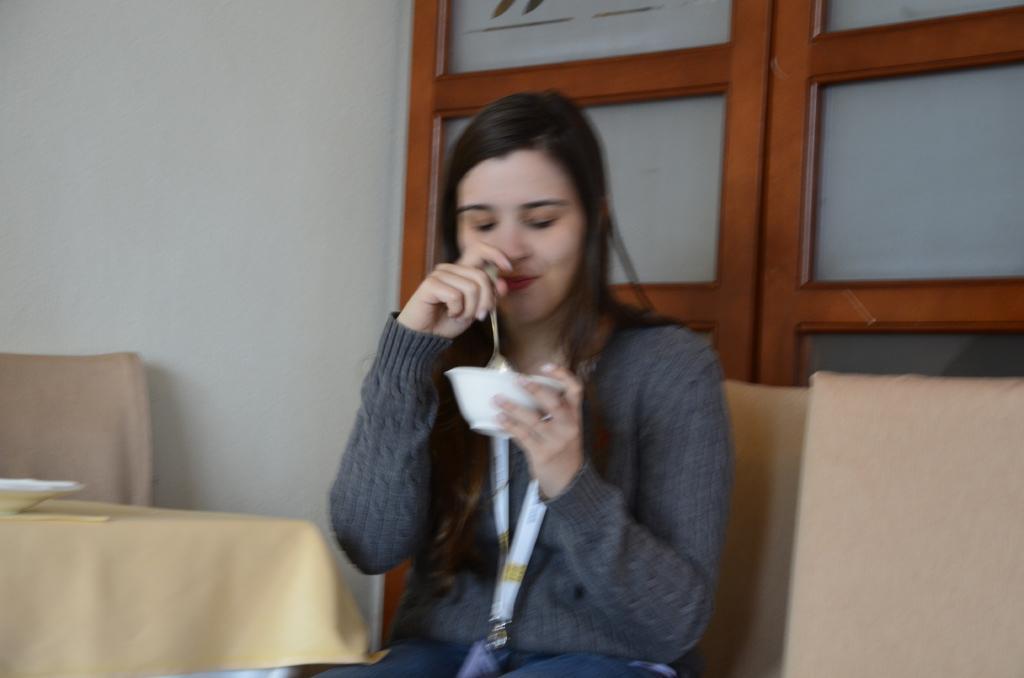How would you summarize this image in a sentence or two? In this image there is a woman holding a bowl with one hand and holding a spoon with the other hand. Beside her there is a table having a bowl. Behind the table there is a chair. Right side there is a chair. Background there is a wall having a window. 